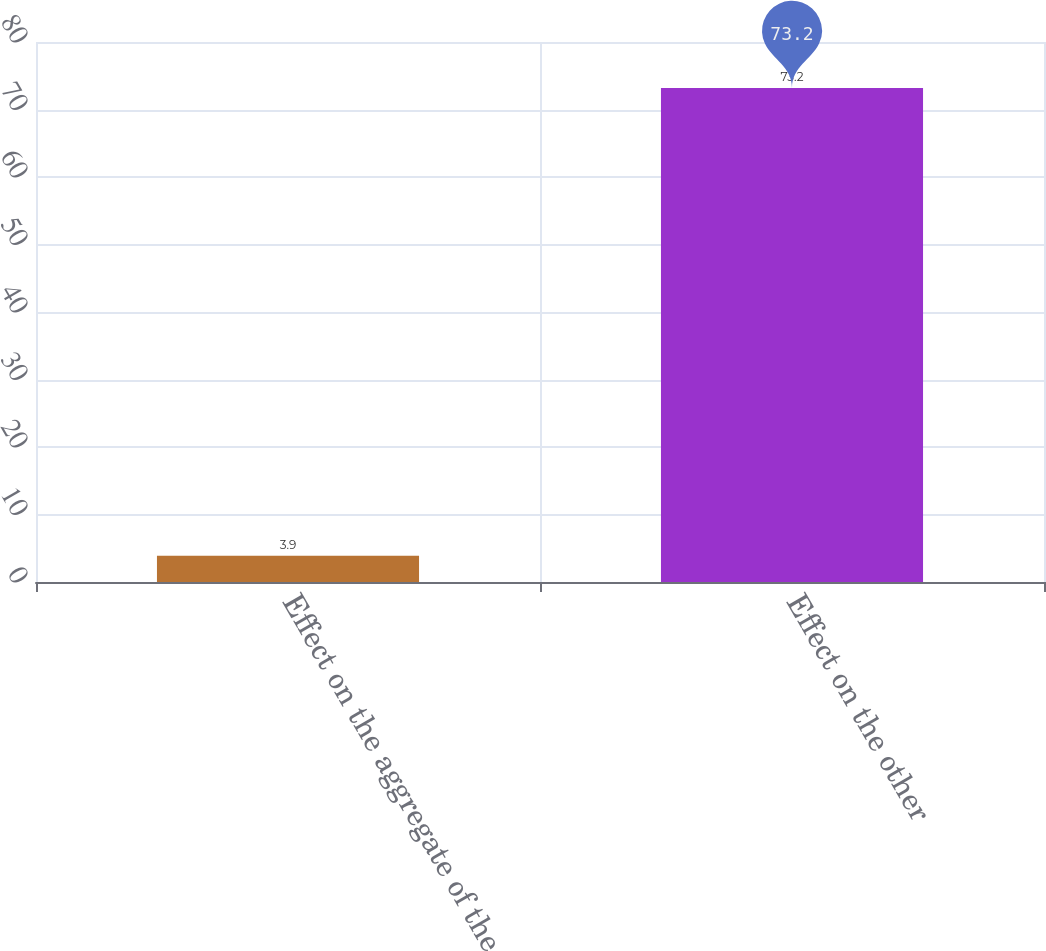Convert chart. <chart><loc_0><loc_0><loc_500><loc_500><bar_chart><fcel>Effect on the aggregate of the<fcel>Effect on the other<nl><fcel>3.9<fcel>73.2<nl></chart> 